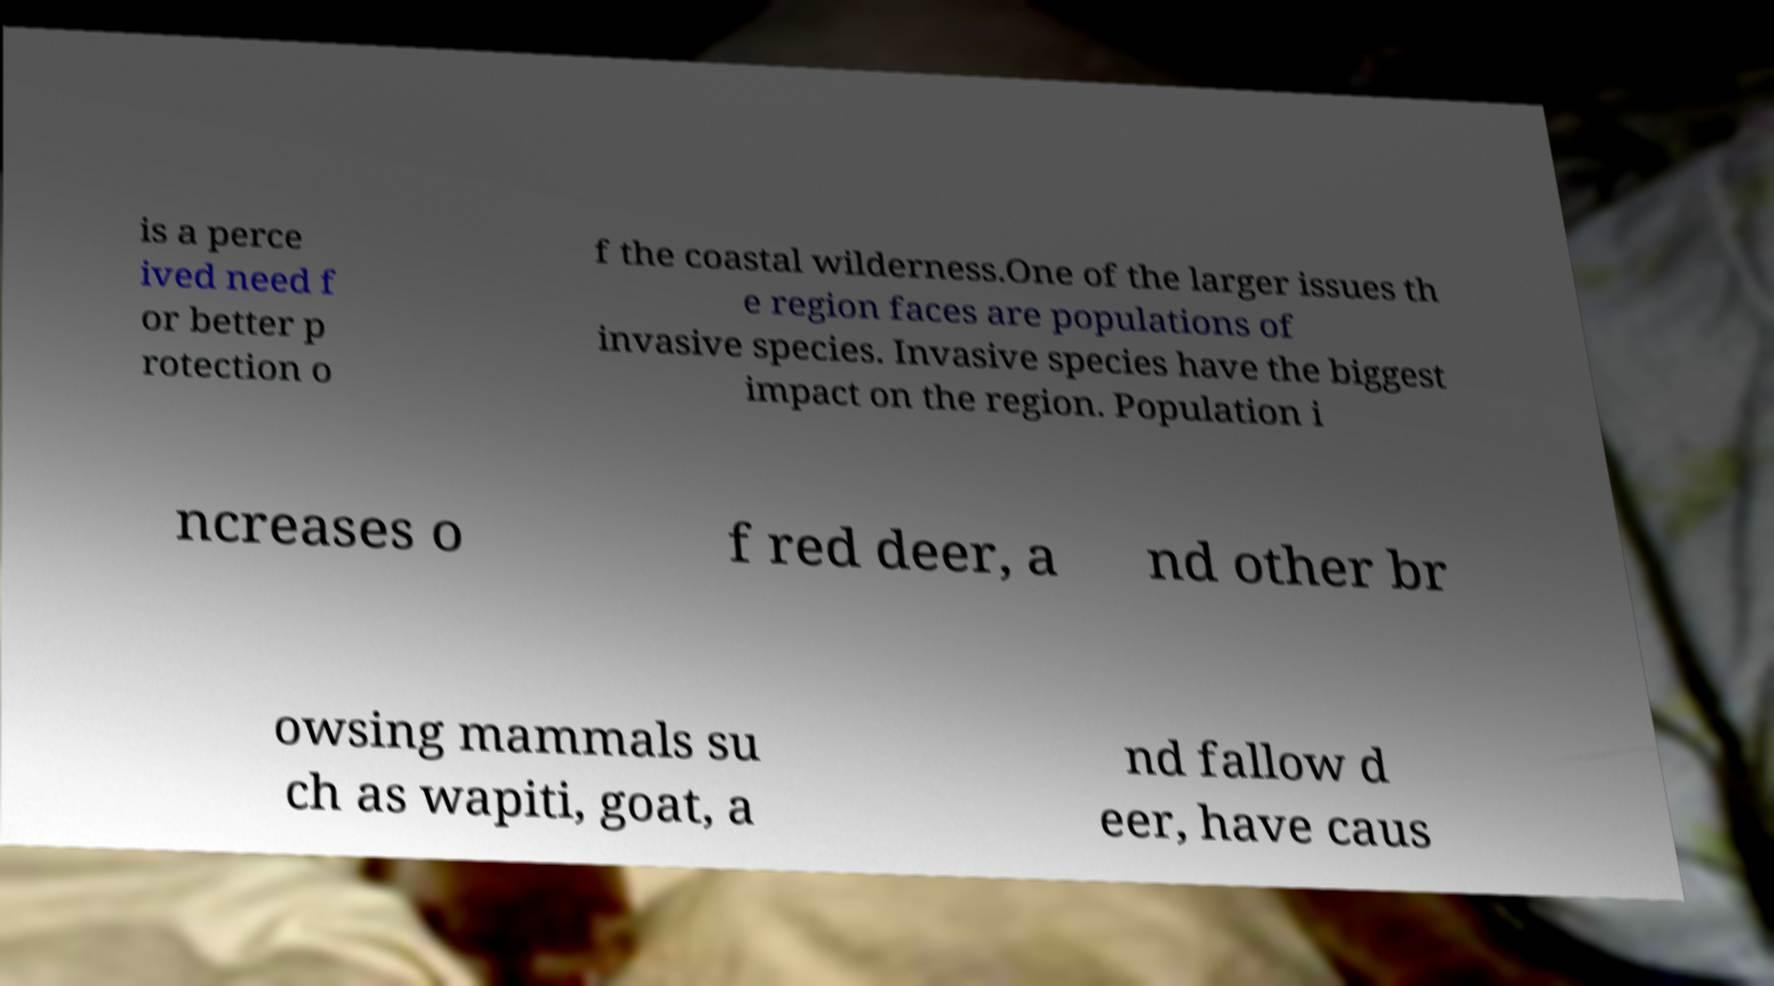There's text embedded in this image that I need extracted. Can you transcribe it verbatim? is a perce ived need f or better p rotection o f the coastal wilderness.One of the larger issues th e region faces are populations of invasive species. Invasive species have the biggest impact on the region. Population i ncreases o f red deer, a nd other br owsing mammals su ch as wapiti, goat, a nd fallow d eer, have caus 